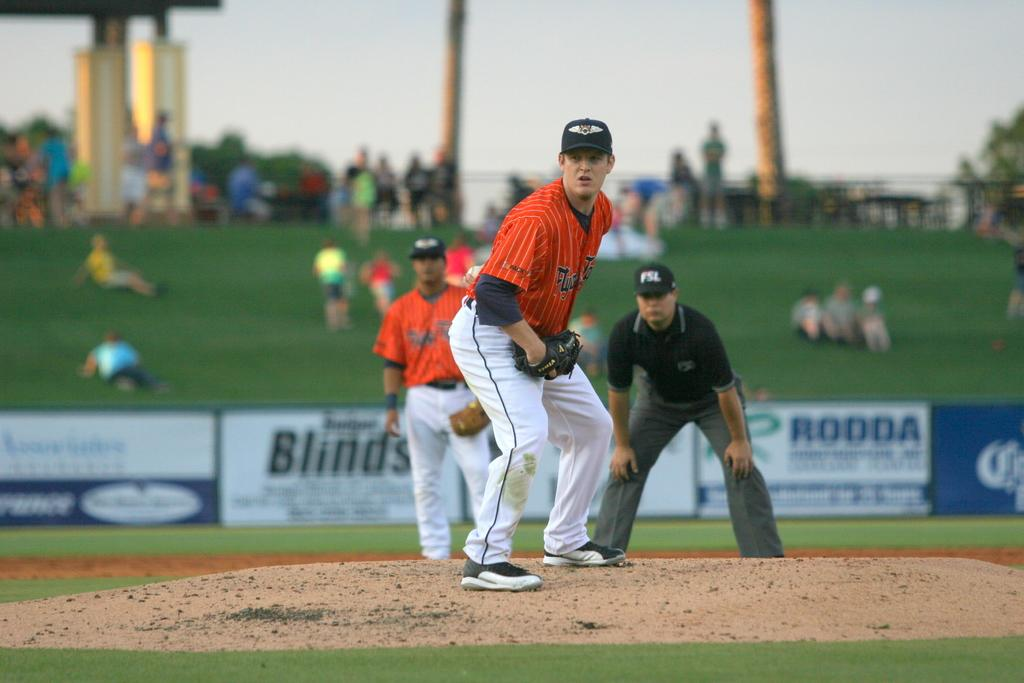<image>
Present a compact description of the photo's key features. An umpire wearing a hat that says "FSL" watching a baseball pitcher prepare to throw. 